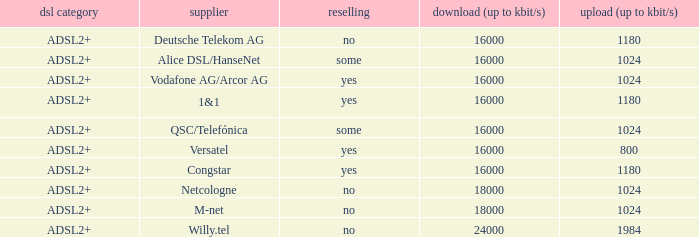What is download bandwith where the provider is deutsche telekom ag? 16000.0. 